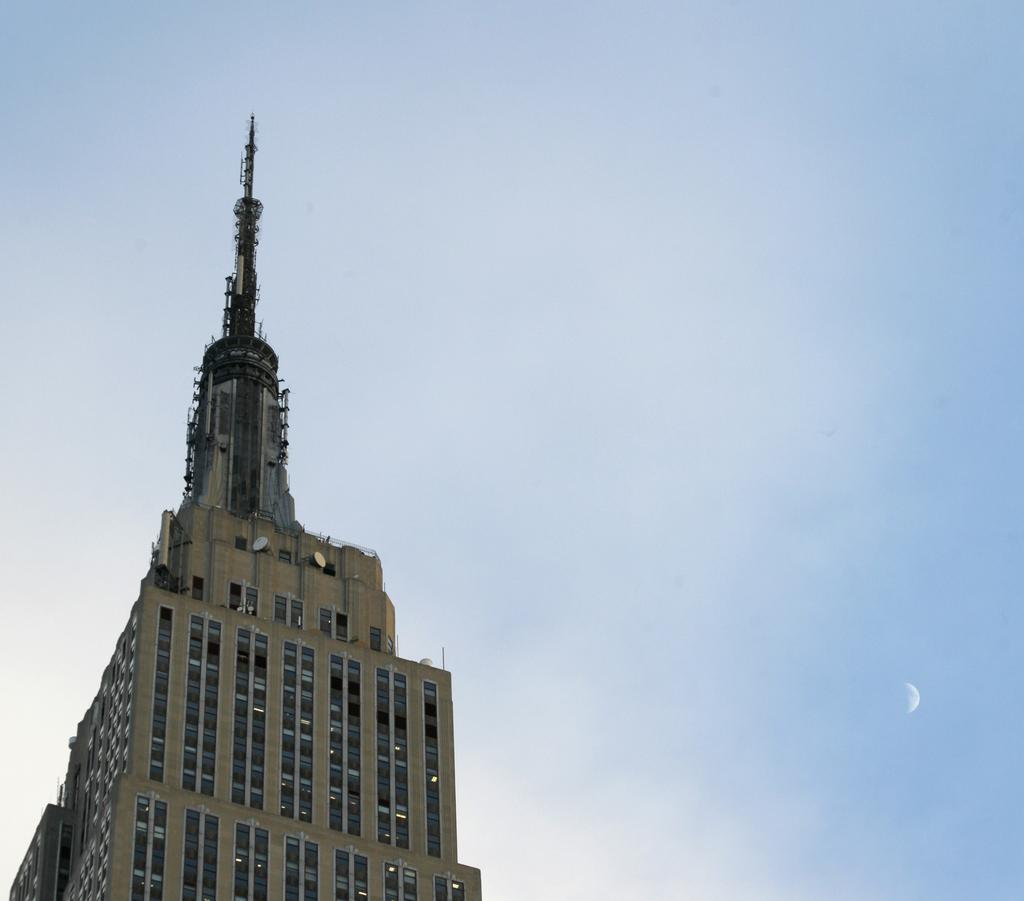What type of structure is visible in the image? There is a building in the image. What can be seen in the background of the image? The sky is visible in the background of the image. What celestial body is present on the right side of the image? The moon is present on the right side of the image. What level of heat can be felt from the person in the image? There is no person present in the image, so it is not possible to determine the level of heat. 